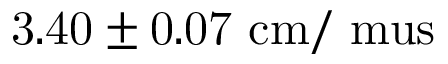<formula> <loc_0><loc_0><loc_500><loc_500>3 . 4 0 \pm 0 . 0 7 c m / \ m u s</formula> 